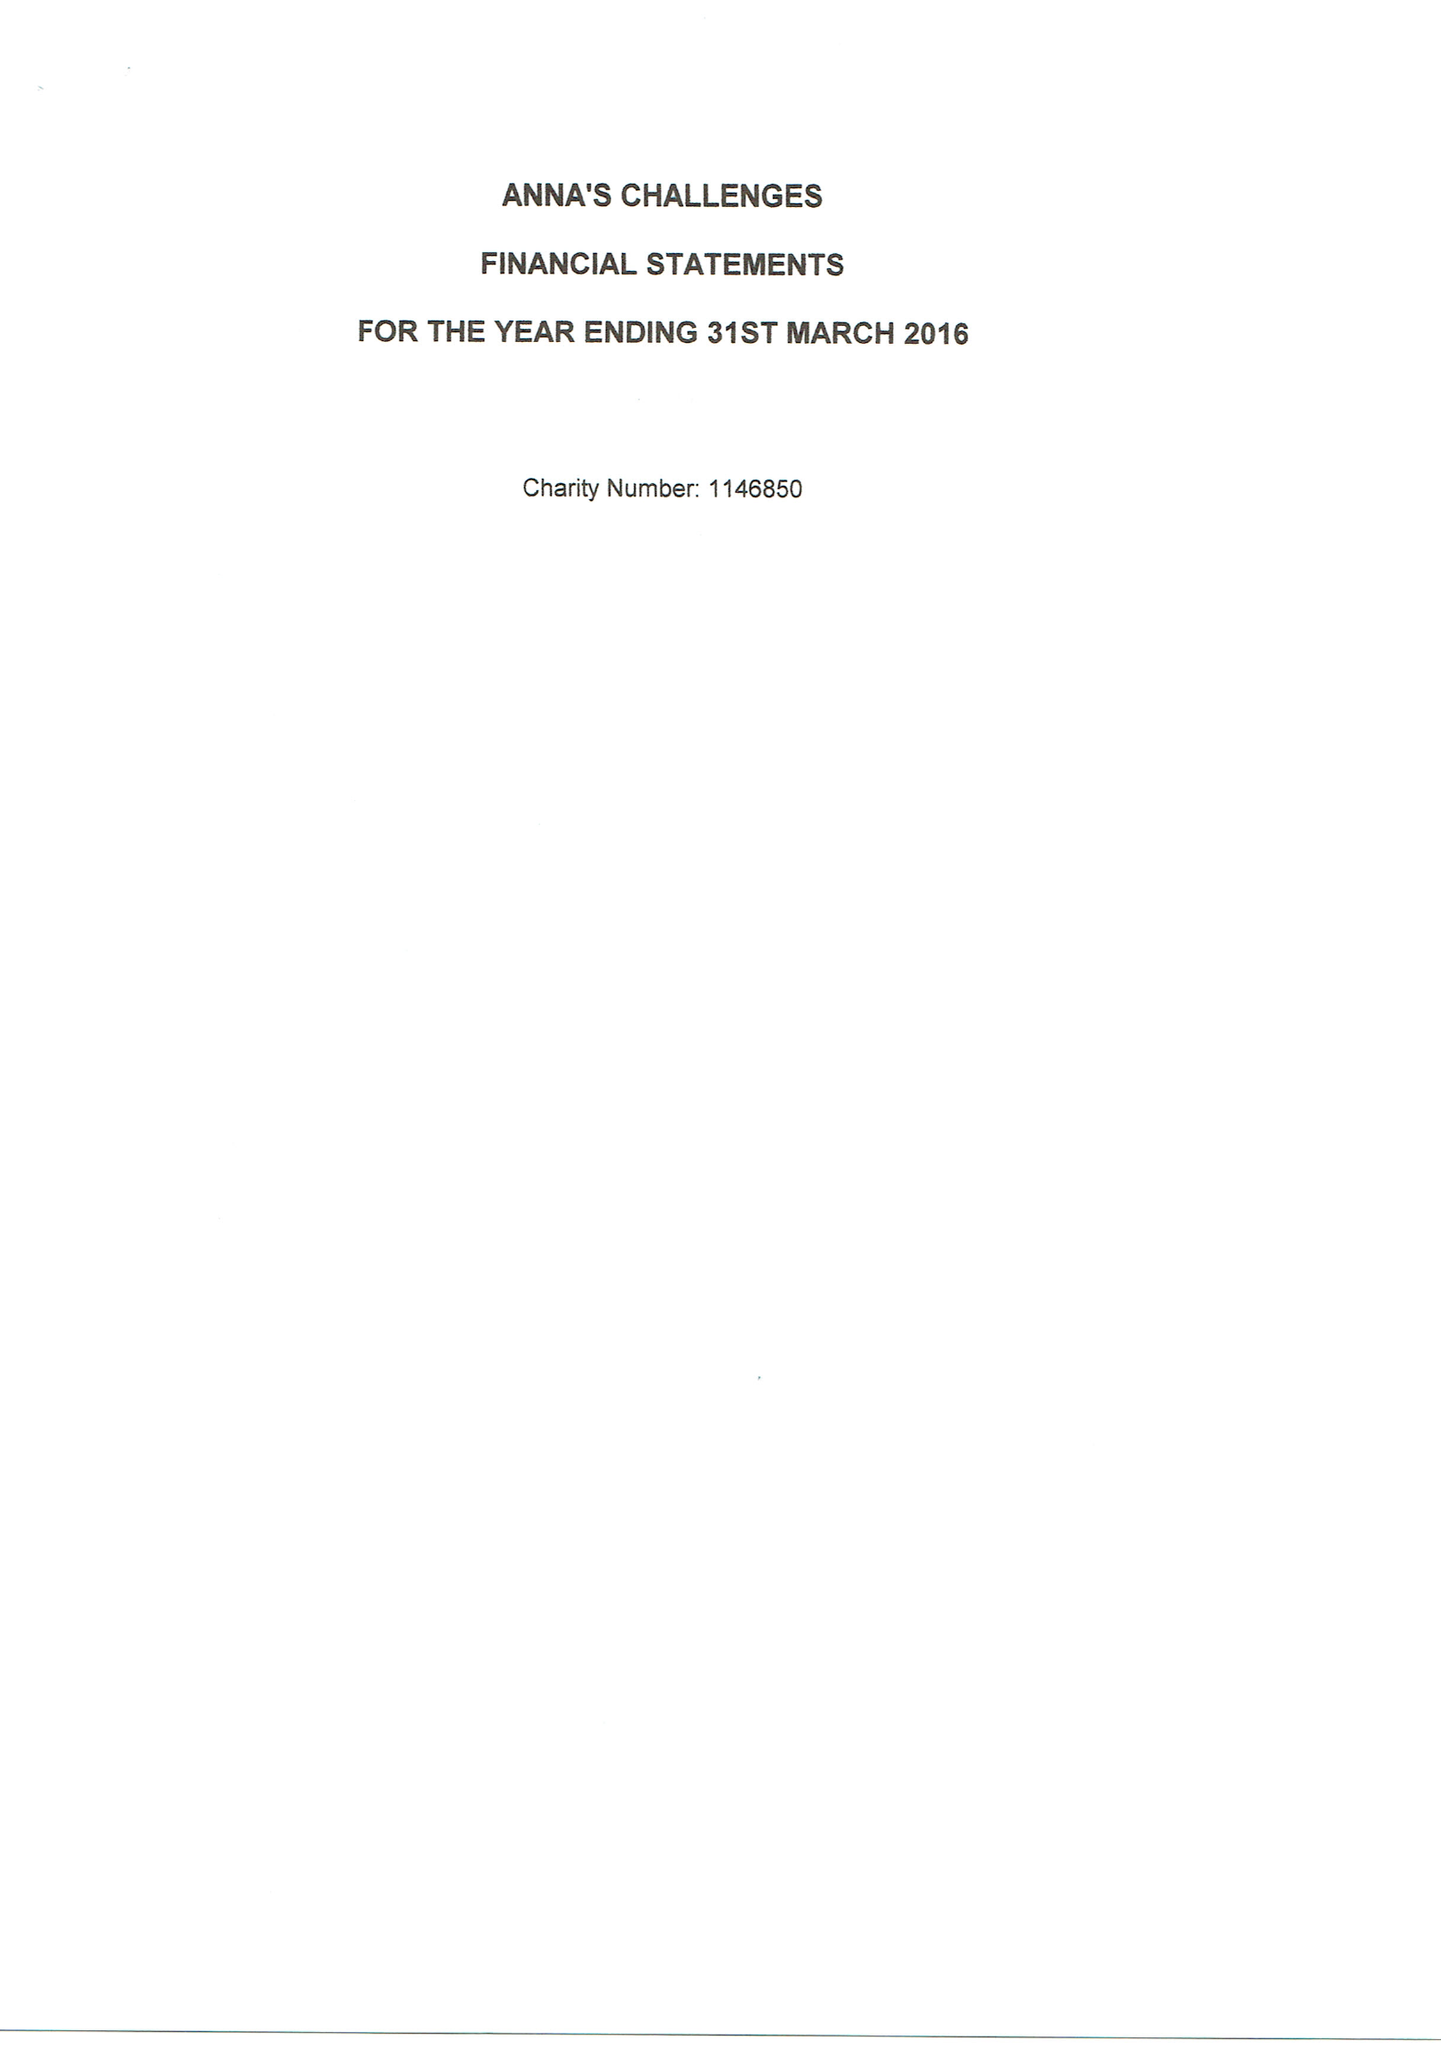What is the value for the income_annually_in_british_pounds?
Answer the question using a single word or phrase. 42753.00 